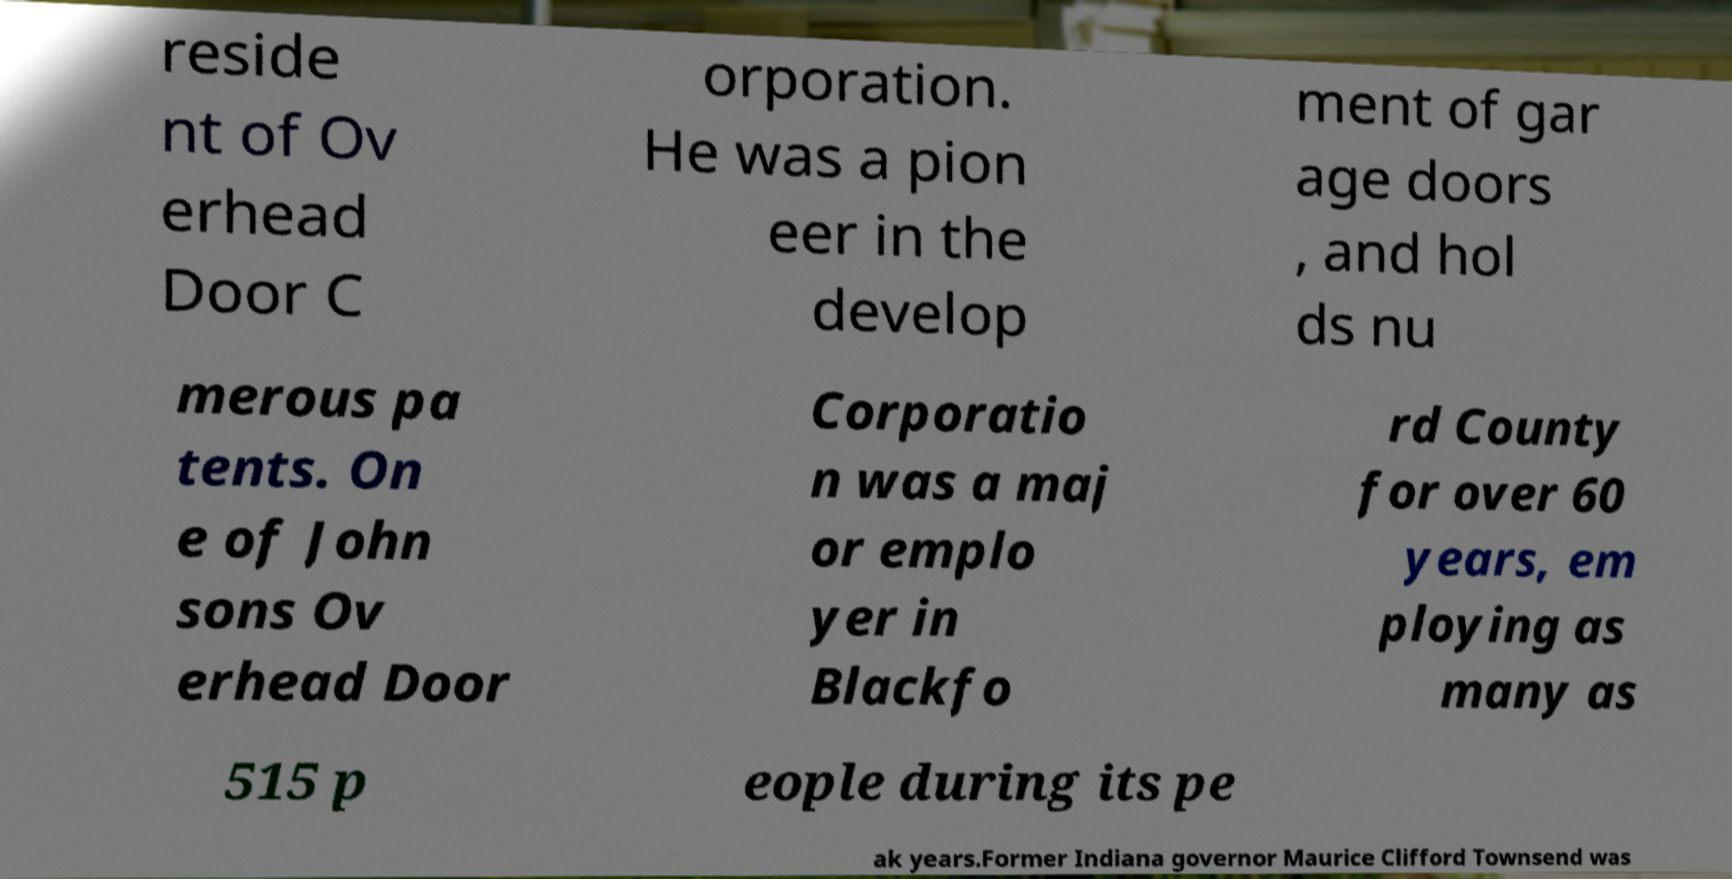What messages or text are displayed in this image? I need them in a readable, typed format. reside nt of Ov erhead Door C orporation. He was a pion eer in the develop ment of gar age doors , and hol ds nu merous pa tents. On e of John sons Ov erhead Door Corporatio n was a maj or emplo yer in Blackfo rd County for over 60 years, em ploying as many as 515 p eople during its pe ak years.Former Indiana governor Maurice Clifford Townsend was 